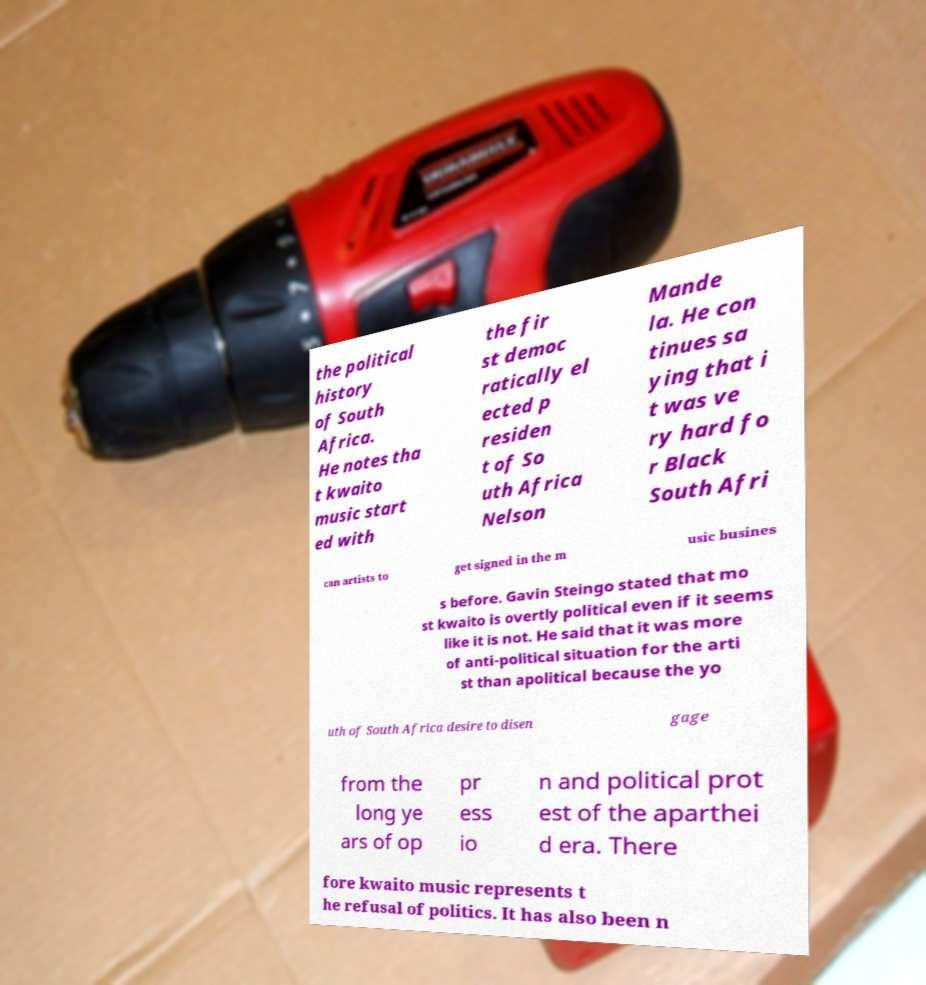Can you read and provide the text displayed in the image?This photo seems to have some interesting text. Can you extract and type it out for me? the political history of South Africa. He notes tha t kwaito music start ed with the fir st democ ratically el ected p residen t of So uth Africa Nelson Mande la. He con tinues sa ying that i t was ve ry hard fo r Black South Afri can artists to get signed in the m usic busines s before. Gavin Steingo stated that mo st kwaito is overtly political even if it seems like it is not. He said that it was more of anti-political situation for the arti st than apolitical because the yo uth of South Africa desire to disen gage from the long ye ars of op pr ess io n and political prot est of the aparthei d era. There fore kwaito music represents t he refusal of politics. It has also been n 